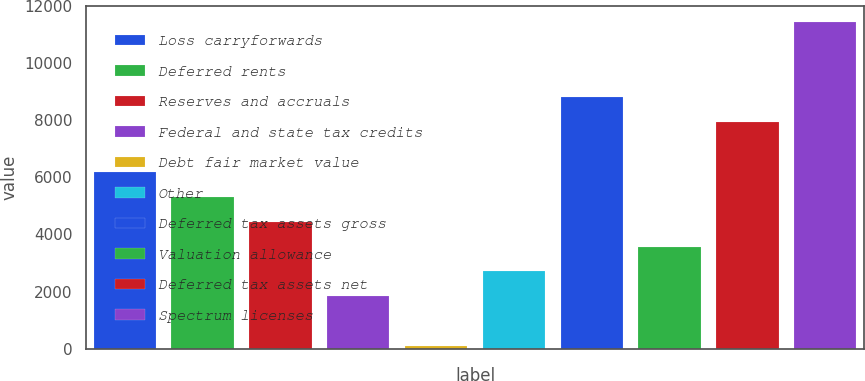Convert chart. <chart><loc_0><loc_0><loc_500><loc_500><bar_chart><fcel>Loss carryforwards<fcel>Deferred rents<fcel>Reserves and accruals<fcel>Federal and state tax credits<fcel>Debt fair market value<fcel>Other<fcel>Deferred tax assets gross<fcel>Valuation allowance<fcel>Deferred tax assets net<fcel>Spectrum licenses<nl><fcel>6195.4<fcel>5322.2<fcel>4449<fcel>1829.4<fcel>83<fcel>2702.6<fcel>8815<fcel>3575.8<fcel>7941.8<fcel>11434.6<nl></chart> 